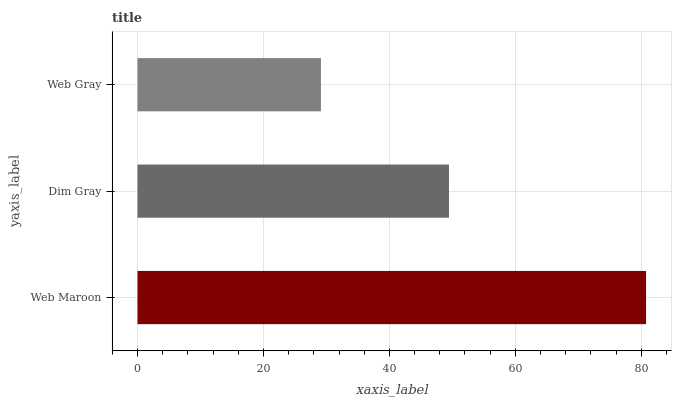Is Web Gray the minimum?
Answer yes or no. Yes. Is Web Maroon the maximum?
Answer yes or no. Yes. Is Dim Gray the minimum?
Answer yes or no. No. Is Dim Gray the maximum?
Answer yes or no. No. Is Web Maroon greater than Dim Gray?
Answer yes or no. Yes. Is Dim Gray less than Web Maroon?
Answer yes or no. Yes. Is Dim Gray greater than Web Maroon?
Answer yes or no. No. Is Web Maroon less than Dim Gray?
Answer yes or no. No. Is Dim Gray the high median?
Answer yes or no. Yes. Is Dim Gray the low median?
Answer yes or no. Yes. Is Web Gray the high median?
Answer yes or no. No. Is Web Gray the low median?
Answer yes or no. No. 